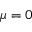<formula> <loc_0><loc_0><loc_500><loc_500>\mu = 0</formula> 